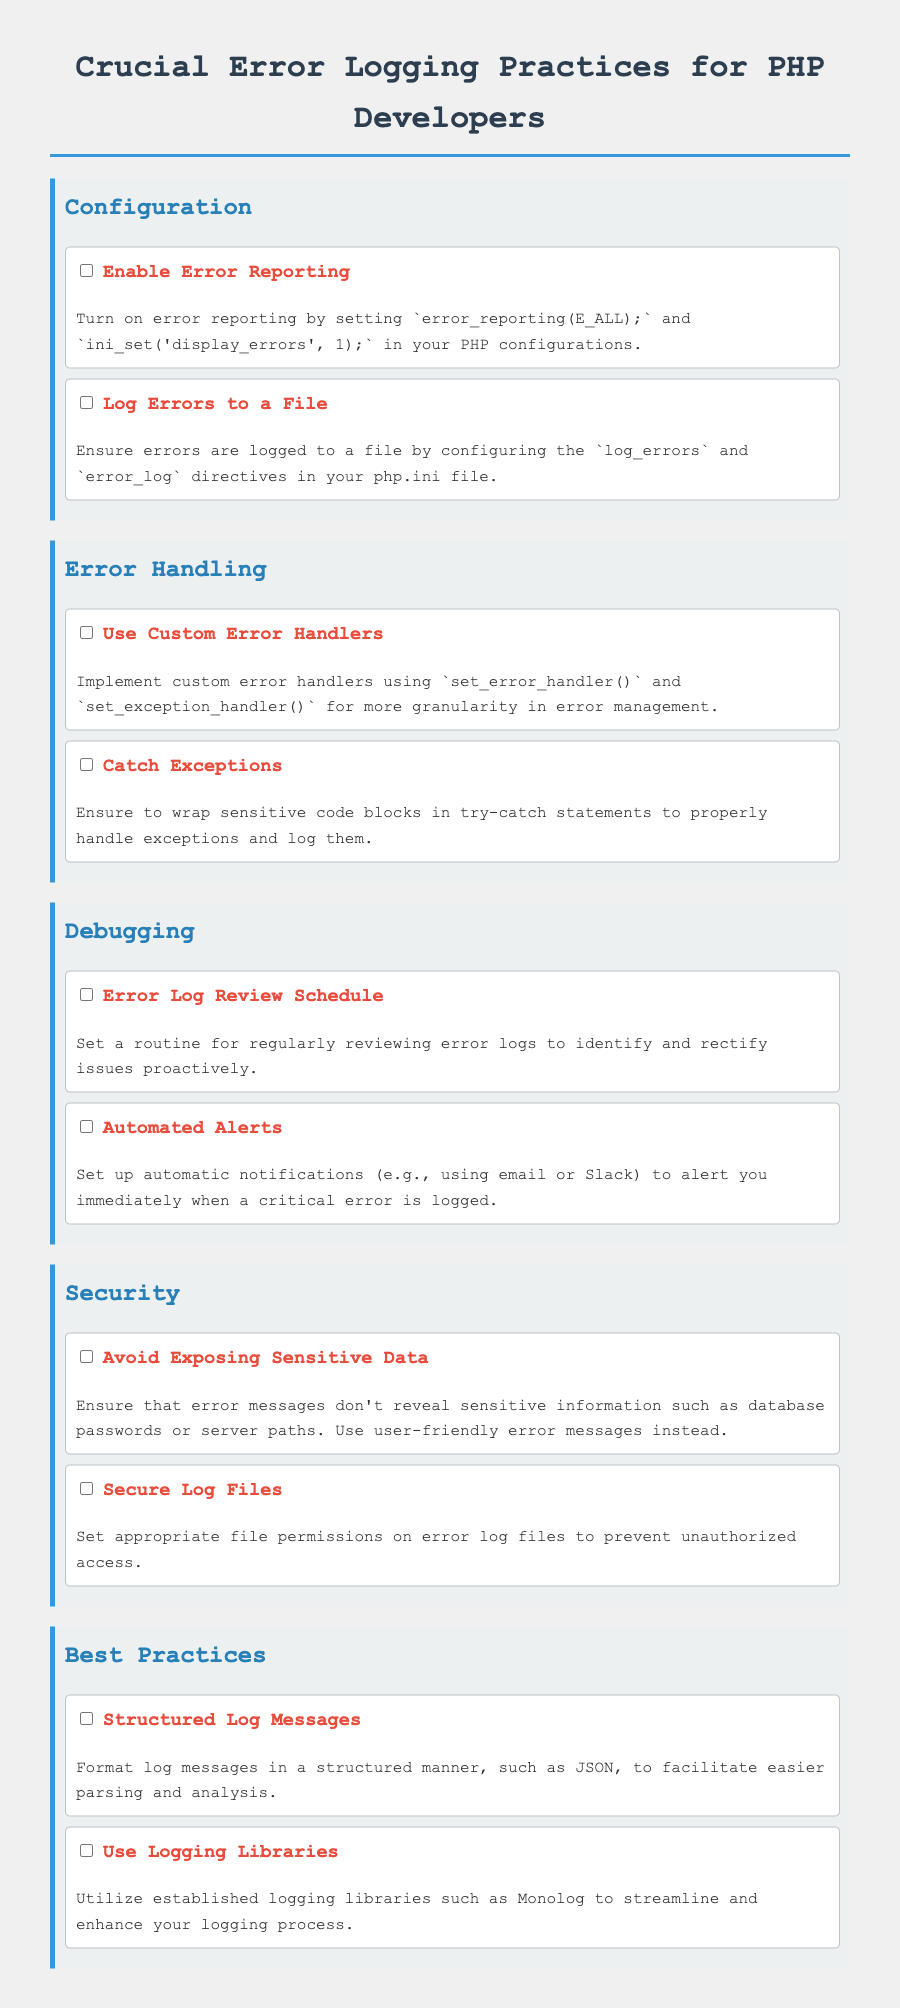What is the main title of the document? The title is prominently displayed as the main heading of the document, which is "Crucial Error Logging Practices for PHP Developers."
Answer: Crucial Error Logging Practices for PHP Developers How many categories are there in the checklist? The document contains four distinct categories listed as Configuration, Error Handling, Debugging, Security, and Best Practices.
Answer: Five Which function is used to implement custom error handlers? The document specifies using the `set_error_handler()` function to implement custom error handlers.
Answer: set_error_handler() What is advised to ensure regarding error messages? The document states to avoid revealing sensitive information in error messages for security reasons.
Answer: Avoid Exposing Sensitive Data What is the benefit of using logging libraries as mentioned in the best practices? It mentions utilizing established logging libraries to streamline and enhance the logging process.
Answer: Streamline and enhance logging process How often should error logs be reviewed according to the checklist? The document indicates that a regular routine should be established for reviewing error logs.
Answer: Regularly What is suggested to be done with error logs for security? It is recommended to set appropriate file permissions on error log files to prevent unauthorized access.
Answer: Secure Log Files What format is suggested for log messages to facilitate easier analysis? The document suggests formatting log messages in a structured manner, such as JSON, for easier parsing.
Answer: JSON 